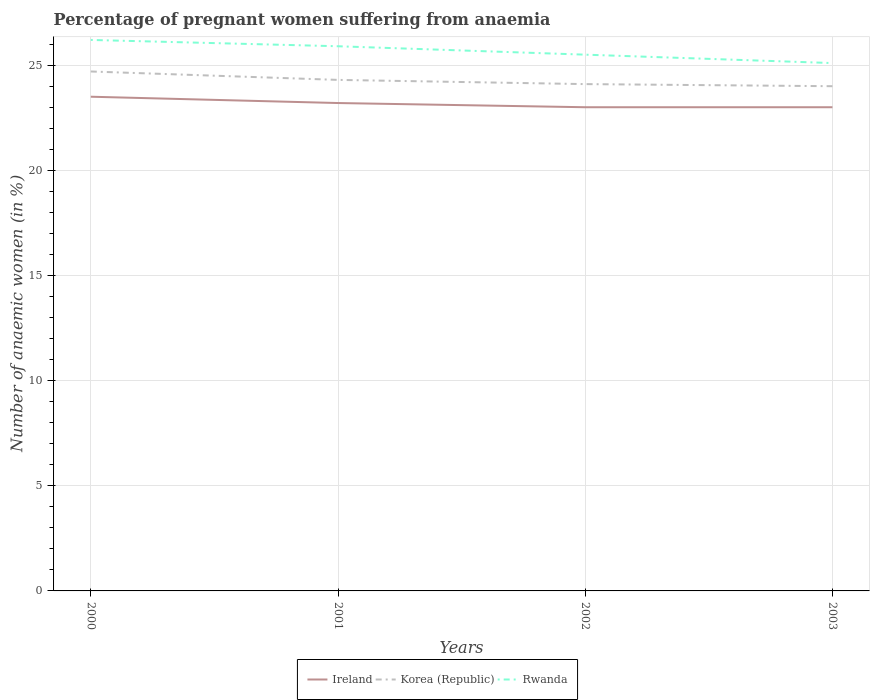How many different coloured lines are there?
Keep it short and to the point. 3. Is the number of lines equal to the number of legend labels?
Give a very brief answer. Yes. Across all years, what is the maximum number of anaemic women in Ireland?
Your answer should be very brief. 23. In which year was the number of anaemic women in Korea (Republic) maximum?
Offer a terse response. 2003. What is the total number of anaemic women in Ireland in the graph?
Give a very brief answer. 0. What is the difference between the highest and the second highest number of anaemic women in Korea (Republic)?
Give a very brief answer. 0.7. Is the number of anaemic women in Ireland strictly greater than the number of anaemic women in Korea (Republic) over the years?
Make the answer very short. Yes. How many lines are there?
Make the answer very short. 3. How many years are there in the graph?
Provide a succinct answer. 4. Are the values on the major ticks of Y-axis written in scientific E-notation?
Your answer should be compact. No. Does the graph contain any zero values?
Your answer should be compact. No. How many legend labels are there?
Provide a succinct answer. 3. How are the legend labels stacked?
Make the answer very short. Horizontal. What is the title of the graph?
Offer a terse response. Percentage of pregnant women suffering from anaemia. What is the label or title of the Y-axis?
Make the answer very short. Number of anaemic women (in %). What is the Number of anaemic women (in %) of Ireland in 2000?
Offer a terse response. 23.5. What is the Number of anaemic women (in %) of Korea (Republic) in 2000?
Your answer should be very brief. 24.7. What is the Number of anaemic women (in %) of Rwanda in 2000?
Give a very brief answer. 26.2. What is the Number of anaemic women (in %) in Ireland in 2001?
Provide a succinct answer. 23.2. What is the Number of anaemic women (in %) in Korea (Republic) in 2001?
Your answer should be compact. 24.3. What is the Number of anaemic women (in %) in Rwanda in 2001?
Your response must be concise. 25.9. What is the Number of anaemic women (in %) in Korea (Republic) in 2002?
Provide a succinct answer. 24.1. What is the Number of anaemic women (in %) of Ireland in 2003?
Ensure brevity in your answer.  23. What is the Number of anaemic women (in %) of Korea (Republic) in 2003?
Provide a short and direct response. 24. What is the Number of anaemic women (in %) of Rwanda in 2003?
Ensure brevity in your answer.  25.1. Across all years, what is the maximum Number of anaemic women (in %) in Korea (Republic)?
Your answer should be very brief. 24.7. Across all years, what is the maximum Number of anaemic women (in %) in Rwanda?
Your answer should be very brief. 26.2. Across all years, what is the minimum Number of anaemic women (in %) of Ireland?
Provide a succinct answer. 23. Across all years, what is the minimum Number of anaemic women (in %) in Korea (Republic)?
Your answer should be compact. 24. Across all years, what is the minimum Number of anaemic women (in %) in Rwanda?
Ensure brevity in your answer.  25.1. What is the total Number of anaemic women (in %) in Ireland in the graph?
Offer a very short reply. 92.7. What is the total Number of anaemic women (in %) of Korea (Republic) in the graph?
Your response must be concise. 97.1. What is the total Number of anaemic women (in %) of Rwanda in the graph?
Provide a succinct answer. 102.7. What is the difference between the Number of anaemic women (in %) of Ireland in 2000 and that in 2002?
Make the answer very short. 0.5. What is the difference between the Number of anaemic women (in %) in Korea (Republic) in 2000 and that in 2002?
Provide a succinct answer. 0.6. What is the difference between the Number of anaemic women (in %) in Rwanda in 2000 and that in 2002?
Make the answer very short. 0.7. What is the difference between the Number of anaemic women (in %) of Korea (Republic) in 2000 and that in 2003?
Your response must be concise. 0.7. What is the difference between the Number of anaemic women (in %) of Ireland in 2001 and that in 2002?
Provide a short and direct response. 0.2. What is the difference between the Number of anaemic women (in %) of Rwanda in 2001 and that in 2002?
Offer a very short reply. 0.4. What is the difference between the Number of anaemic women (in %) of Rwanda in 2001 and that in 2003?
Keep it short and to the point. 0.8. What is the difference between the Number of anaemic women (in %) in Ireland in 2002 and that in 2003?
Offer a very short reply. 0. What is the difference between the Number of anaemic women (in %) in Rwanda in 2002 and that in 2003?
Provide a succinct answer. 0.4. What is the difference between the Number of anaemic women (in %) of Ireland in 2000 and the Number of anaemic women (in %) of Rwanda in 2001?
Offer a terse response. -2.4. What is the difference between the Number of anaemic women (in %) of Ireland in 2000 and the Number of anaemic women (in %) of Korea (Republic) in 2003?
Provide a short and direct response. -0.5. What is the difference between the Number of anaemic women (in %) in Ireland in 2000 and the Number of anaemic women (in %) in Rwanda in 2003?
Provide a short and direct response. -1.6. What is the difference between the Number of anaemic women (in %) in Ireland in 2001 and the Number of anaemic women (in %) in Korea (Republic) in 2002?
Your answer should be very brief. -0.9. What is the difference between the Number of anaemic women (in %) in Korea (Republic) in 2001 and the Number of anaemic women (in %) in Rwanda in 2002?
Ensure brevity in your answer.  -1.2. What is the difference between the Number of anaemic women (in %) in Ireland in 2001 and the Number of anaemic women (in %) in Korea (Republic) in 2003?
Offer a terse response. -0.8. What is the difference between the Number of anaemic women (in %) of Korea (Republic) in 2001 and the Number of anaemic women (in %) of Rwanda in 2003?
Provide a succinct answer. -0.8. What is the difference between the Number of anaemic women (in %) in Ireland in 2002 and the Number of anaemic women (in %) in Rwanda in 2003?
Give a very brief answer. -2.1. What is the difference between the Number of anaemic women (in %) of Korea (Republic) in 2002 and the Number of anaemic women (in %) of Rwanda in 2003?
Ensure brevity in your answer.  -1. What is the average Number of anaemic women (in %) of Ireland per year?
Keep it short and to the point. 23.18. What is the average Number of anaemic women (in %) in Korea (Republic) per year?
Provide a succinct answer. 24.27. What is the average Number of anaemic women (in %) of Rwanda per year?
Provide a succinct answer. 25.68. In the year 2000, what is the difference between the Number of anaemic women (in %) of Ireland and Number of anaemic women (in %) of Rwanda?
Keep it short and to the point. -2.7. In the year 2000, what is the difference between the Number of anaemic women (in %) in Korea (Republic) and Number of anaemic women (in %) in Rwanda?
Keep it short and to the point. -1.5. In the year 2001, what is the difference between the Number of anaemic women (in %) of Ireland and Number of anaemic women (in %) of Korea (Republic)?
Ensure brevity in your answer.  -1.1. In the year 2001, what is the difference between the Number of anaemic women (in %) of Korea (Republic) and Number of anaemic women (in %) of Rwanda?
Provide a succinct answer. -1.6. In the year 2002, what is the difference between the Number of anaemic women (in %) of Ireland and Number of anaemic women (in %) of Korea (Republic)?
Provide a succinct answer. -1.1. In the year 2002, what is the difference between the Number of anaemic women (in %) in Ireland and Number of anaemic women (in %) in Rwanda?
Ensure brevity in your answer.  -2.5. What is the ratio of the Number of anaemic women (in %) in Ireland in 2000 to that in 2001?
Ensure brevity in your answer.  1.01. What is the ratio of the Number of anaemic women (in %) of Korea (Republic) in 2000 to that in 2001?
Your response must be concise. 1.02. What is the ratio of the Number of anaemic women (in %) of Rwanda in 2000 to that in 2001?
Offer a terse response. 1.01. What is the ratio of the Number of anaemic women (in %) of Ireland in 2000 to that in 2002?
Your response must be concise. 1.02. What is the ratio of the Number of anaemic women (in %) in Korea (Republic) in 2000 to that in 2002?
Ensure brevity in your answer.  1.02. What is the ratio of the Number of anaemic women (in %) in Rwanda in 2000 to that in 2002?
Your answer should be compact. 1.03. What is the ratio of the Number of anaemic women (in %) in Ireland in 2000 to that in 2003?
Offer a very short reply. 1.02. What is the ratio of the Number of anaemic women (in %) of Korea (Republic) in 2000 to that in 2003?
Your answer should be very brief. 1.03. What is the ratio of the Number of anaemic women (in %) in Rwanda in 2000 to that in 2003?
Offer a terse response. 1.04. What is the ratio of the Number of anaemic women (in %) of Ireland in 2001 to that in 2002?
Keep it short and to the point. 1.01. What is the ratio of the Number of anaemic women (in %) of Korea (Republic) in 2001 to that in 2002?
Your answer should be compact. 1.01. What is the ratio of the Number of anaemic women (in %) in Rwanda in 2001 to that in 2002?
Make the answer very short. 1.02. What is the ratio of the Number of anaemic women (in %) in Ireland in 2001 to that in 2003?
Offer a terse response. 1.01. What is the ratio of the Number of anaemic women (in %) of Korea (Republic) in 2001 to that in 2003?
Your answer should be compact. 1.01. What is the ratio of the Number of anaemic women (in %) of Rwanda in 2001 to that in 2003?
Your answer should be compact. 1.03. What is the ratio of the Number of anaemic women (in %) in Ireland in 2002 to that in 2003?
Your answer should be compact. 1. What is the ratio of the Number of anaemic women (in %) of Rwanda in 2002 to that in 2003?
Your answer should be compact. 1.02. What is the difference between the highest and the second highest Number of anaemic women (in %) in Korea (Republic)?
Keep it short and to the point. 0.4. What is the difference between the highest and the second highest Number of anaemic women (in %) in Rwanda?
Your answer should be very brief. 0.3. What is the difference between the highest and the lowest Number of anaemic women (in %) in Ireland?
Ensure brevity in your answer.  0.5. What is the difference between the highest and the lowest Number of anaemic women (in %) of Rwanda?
Provide a succinct answer. 1.1. 